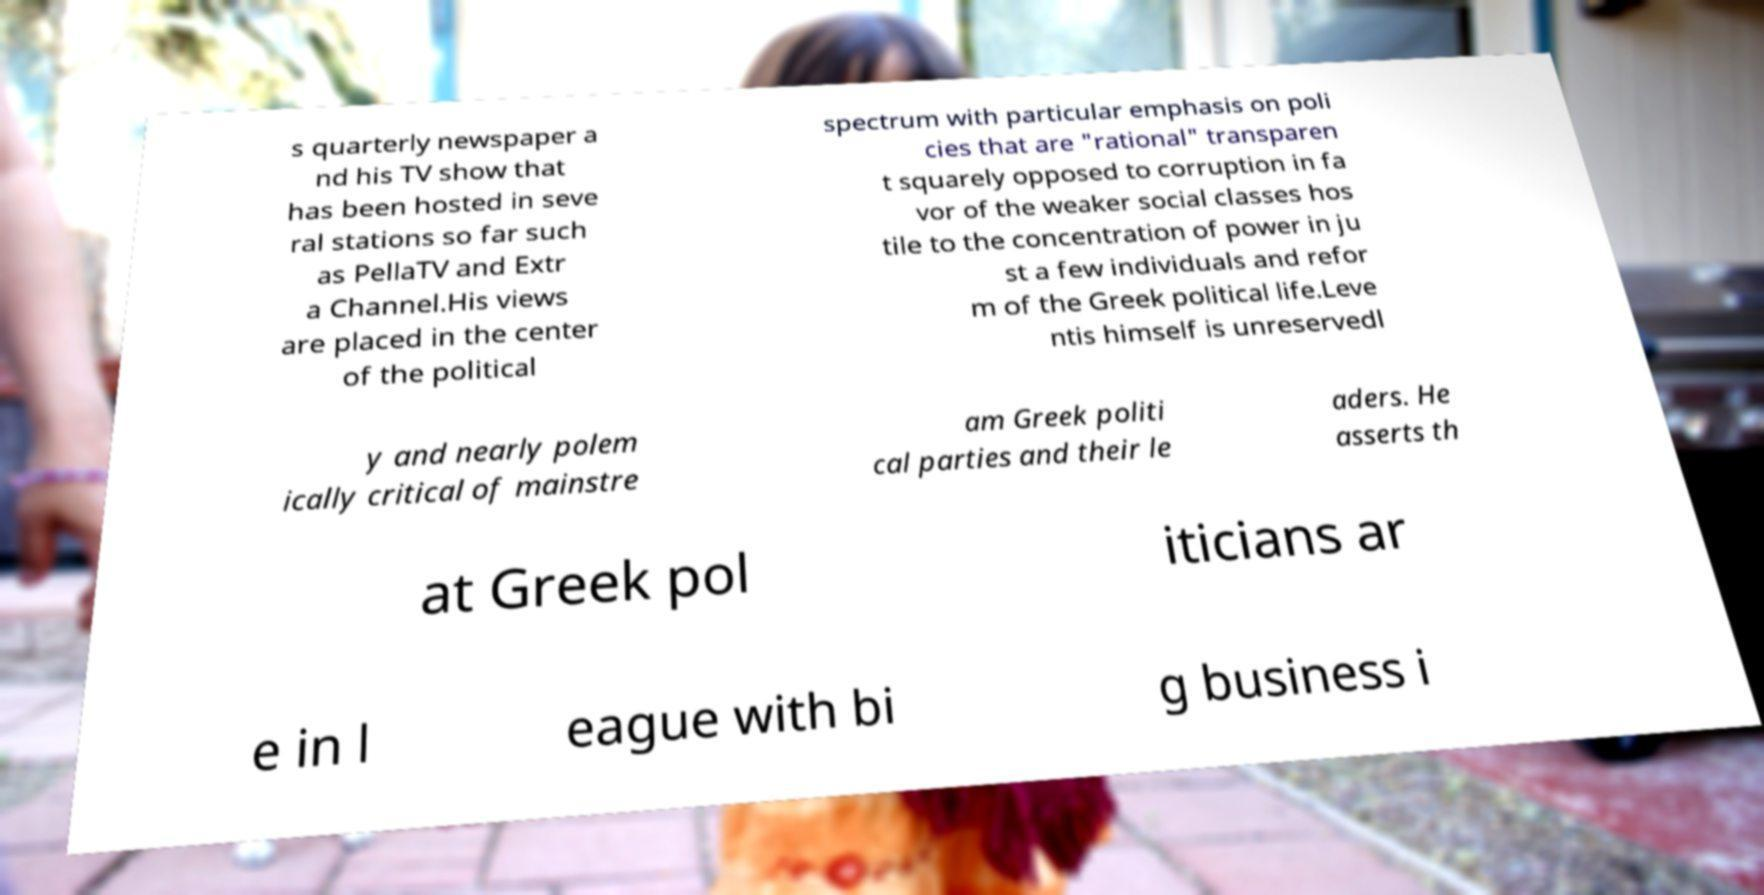What messages or text are displayed in this image? I need them in a readable, typed format. s quarterly newspaper a nd his TV show that has been hosted in seve ral stations so far such as PellaTV and Extr a Channel.His views are placed in the center of the political spectrum with particular emphasis on poli cies that are "rational" transparen t squarely opposed to corruption in fa vor of the weaker social classes hos tile to the concentration of power in ju st a few individuals and refor m of the Greek political life.Leve ntis himself is unreservedl y and nearly polem ically critical of mainstre am Greek politi cal parties and their le aders. He asserts th at Greek pol iticians ar e in l eague with bi g business i 